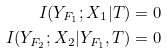Convert formula to latex. <formula><loc_0><loc_0><loc_500><loc_500>I ( Y _ { F _ { 1 } } ; X _ { 1 } | T ) & = 0 \\ I ( Y _ { F _ { 2 } } ; X _ { 2 } | Y _ { F _ { 1 } } , T ) & = 0</formula> 